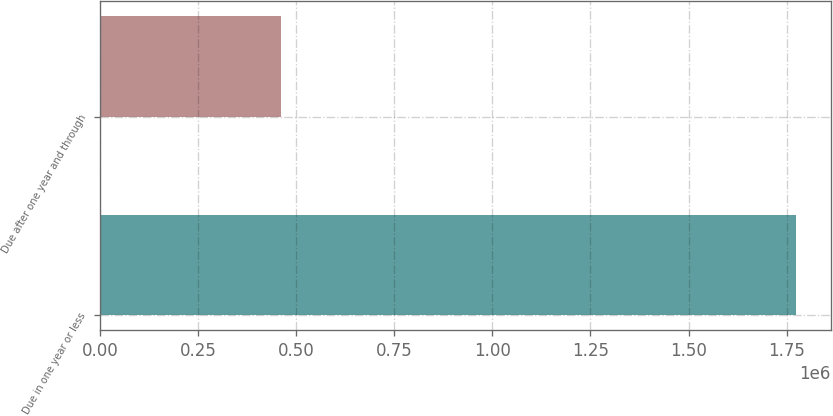Convert chart. <chart><loc_0><loc_0><loc_500><loc_500><bar_chart><fcel>Due in one year or less<fcel>Due after one year and through<nl><fcel>1.77393e+06<fcel>462010<nl></chart> 